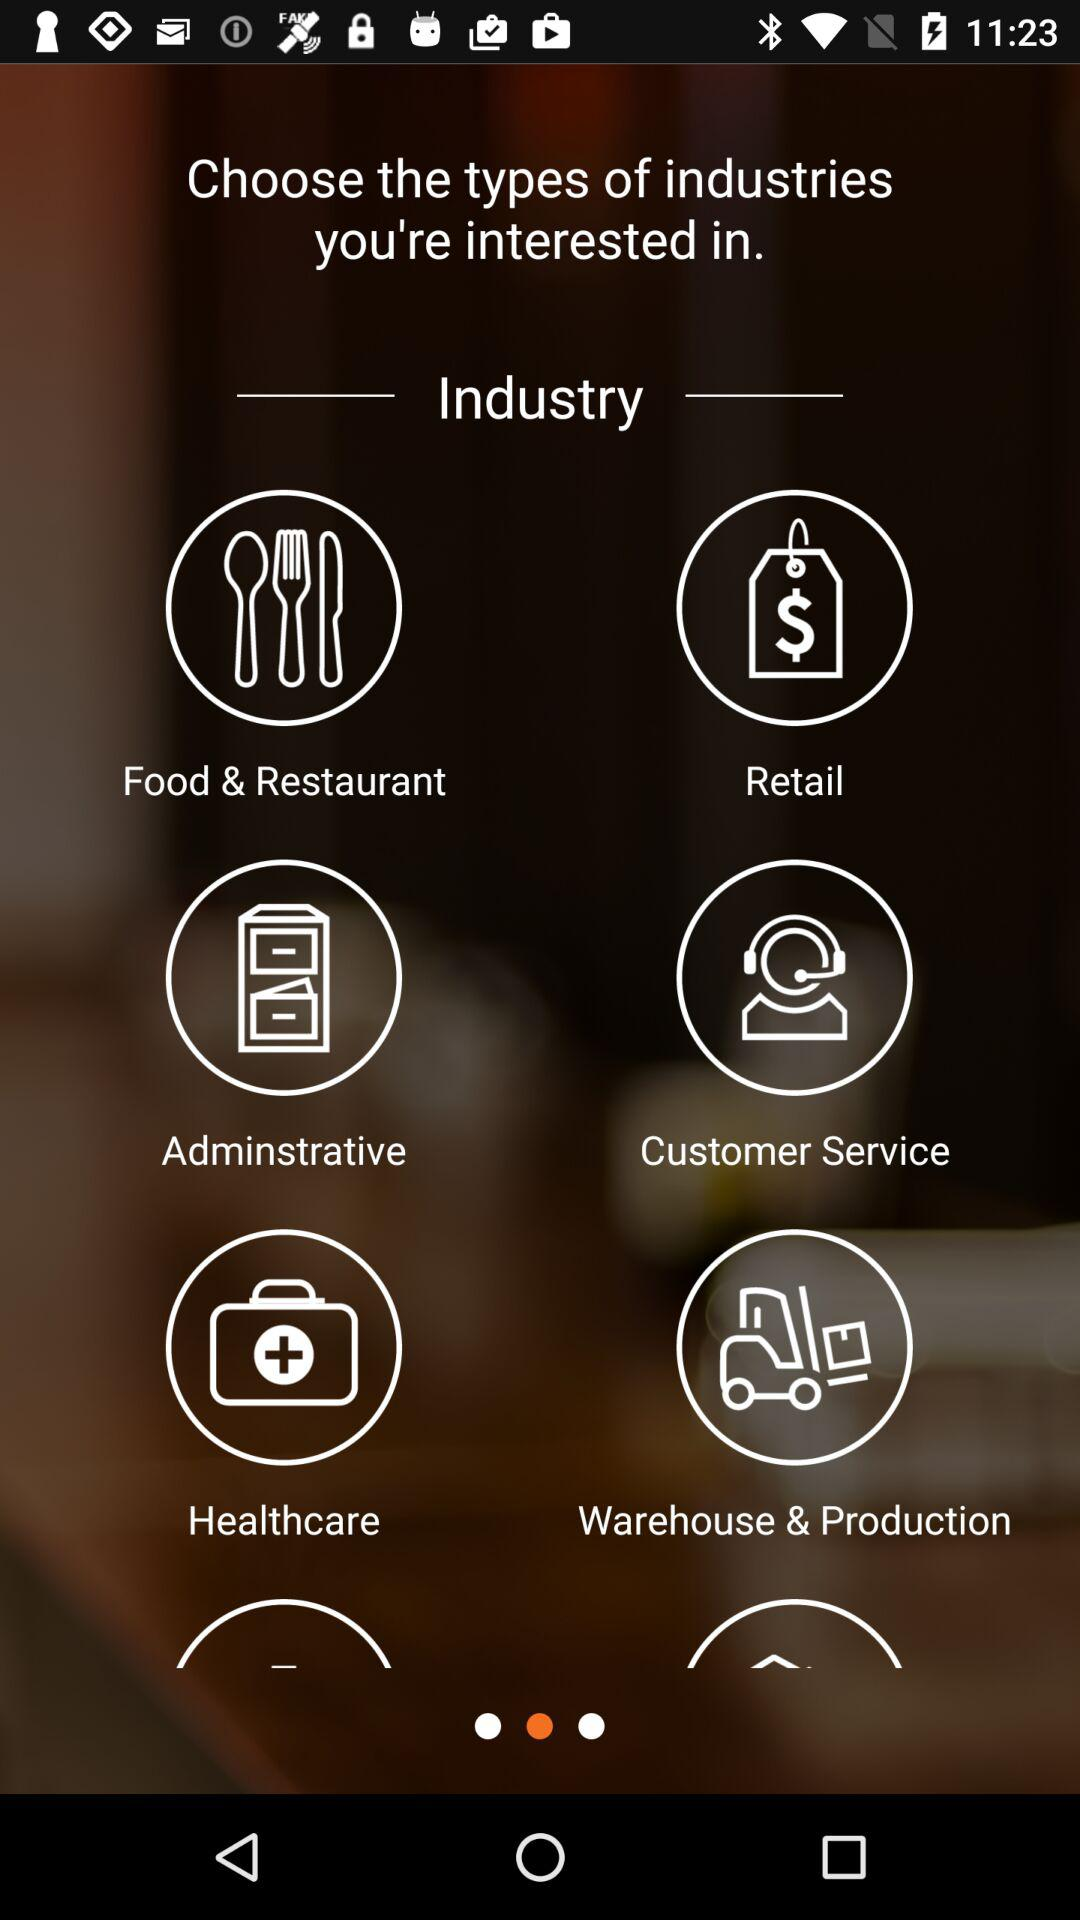What are the types of industries that I can select as per my interests? The types of industries are "Food & Restaurant", "Retail", "Adminstrative", "Customer Service", "Healthcare" and "Warehouse & Production". 